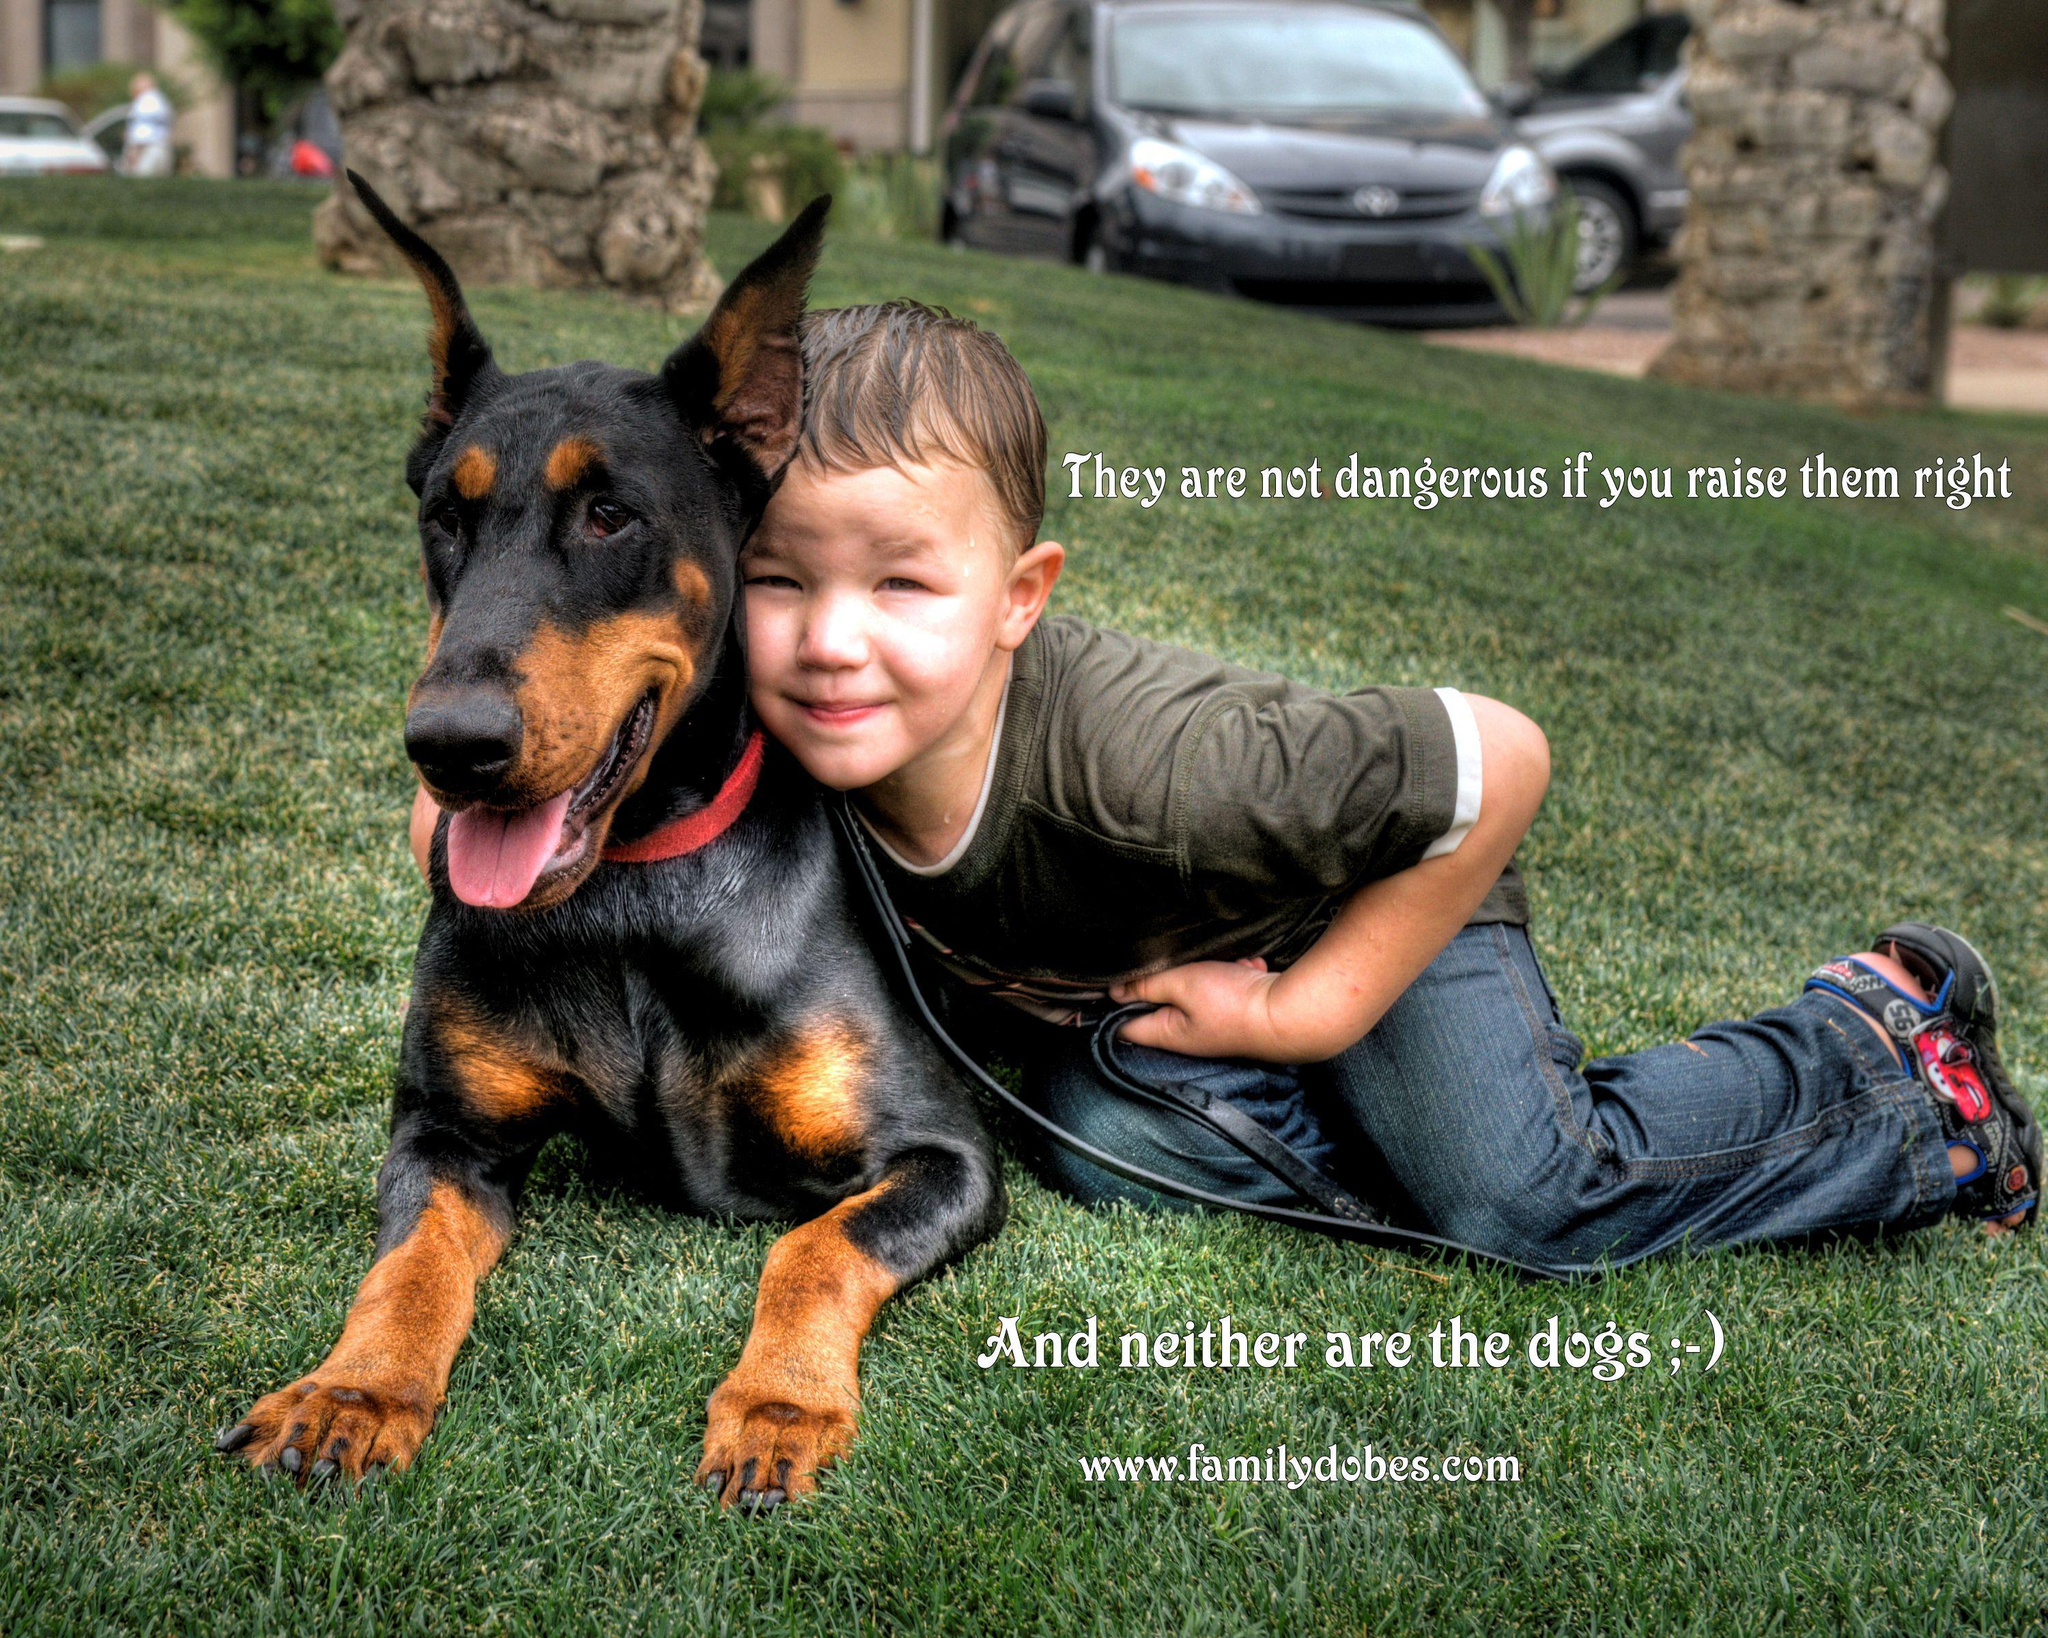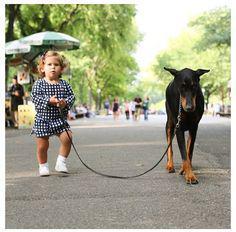The first image is the image on the left, the second image is the image on the right. For the images shown, is this caption "There are at least three dogs in total." true? Answer yes or no. No. The first image is the image on the left, the second image is the image on the right. For the images shown, is this caption "A young girl is sitting next to her doberman pincer." true? Answer yes or no. No. 